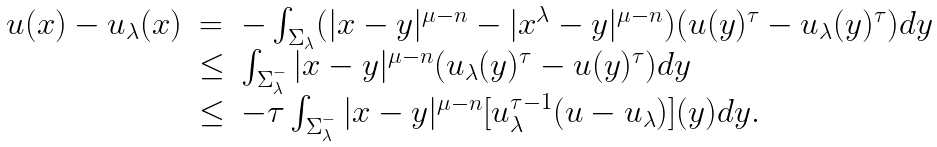Convert formula to latex. <formula><loc_0><loc_0><loc_500><loc_500>\begin{array} { l l l } u ( x ) - u _ { \lambda } ( x ) & = & - \int _ { \Sigma _ { \lambda } } ( | x - y | ^ { \mu - n } - | x ^ { \lambda } - y | ^ { \mu - n } ) ( u ( y ) ^ { \tau } - u _ { \lambda } ( y ) ^ { \tau } ) d y \\ & \leq & \int _ { \Sigma _ { \lambda } ^ { - } } | x - y | ^ { \mu - n } ( u _ { \lambda } ( y ) ^ { \tau } - u ( y ) ^ { \tau } ) d y \\ & \leq & - \tau \int _ { \Sigma _ { \lambda } ^ { - } } | x - y | ^ { \mu - n } [ u _ { \lambda } ^ { \tau - 1 } ( u - u _ { \lambda } ) ] ( y ) d y . \end{array}</formula> 